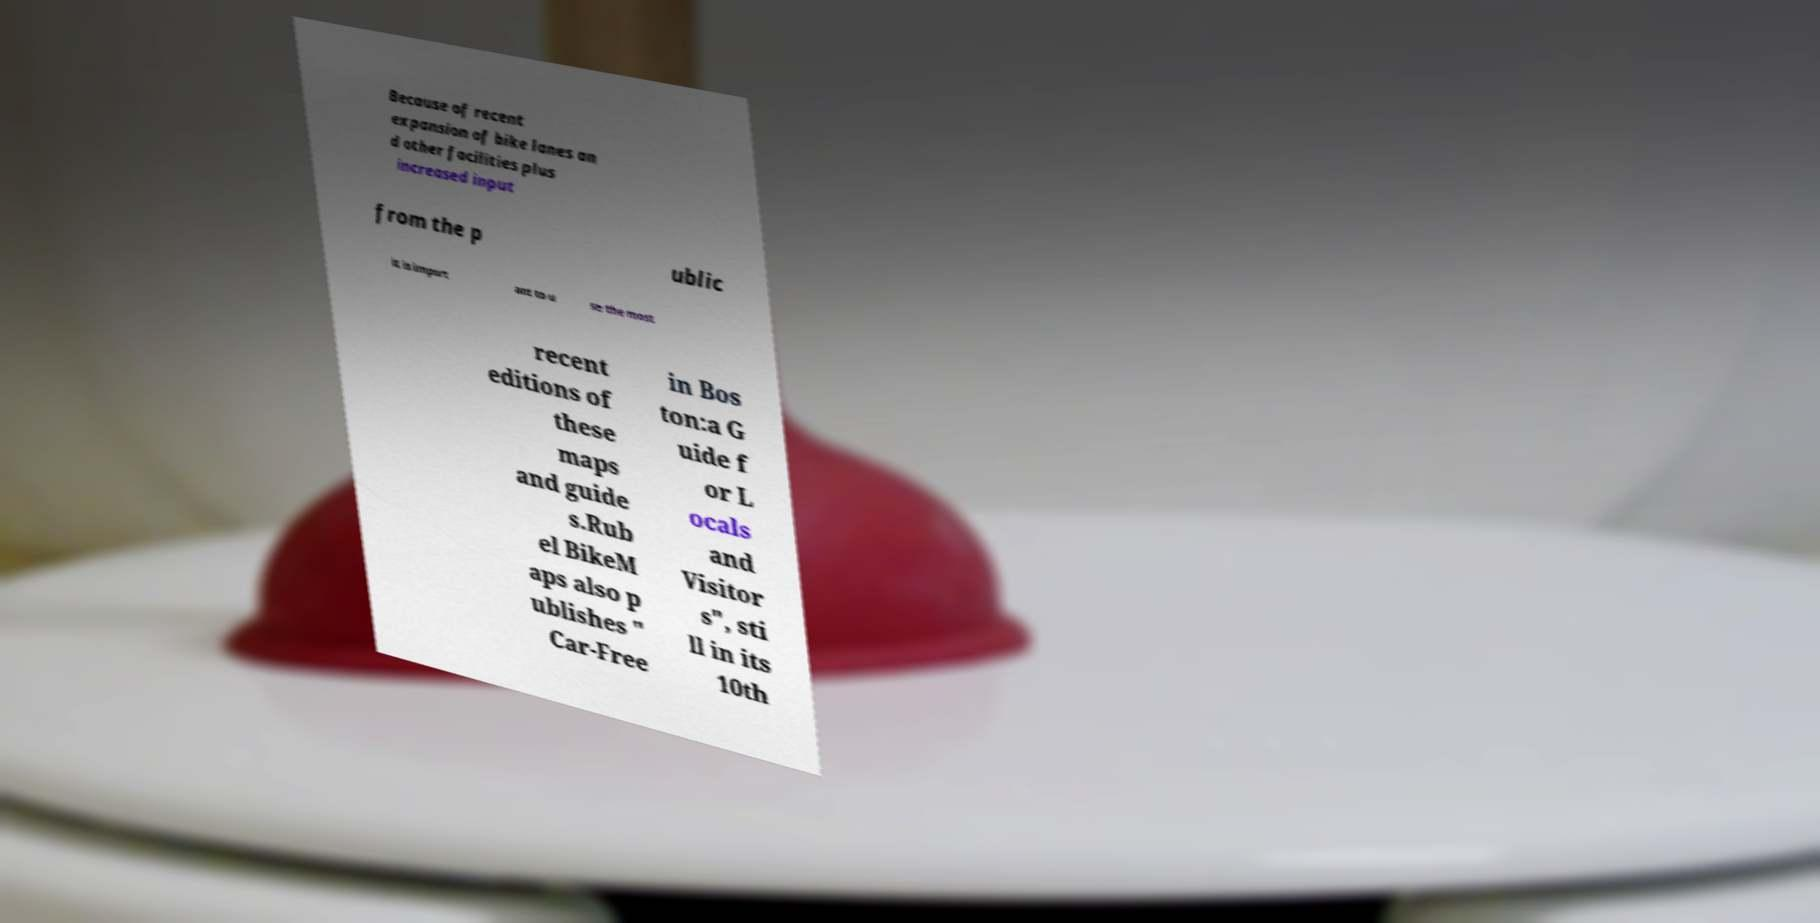There's text embedded in this image that I need extracted. Can you transcribe it verbatim? Because of recent expansion of bike lanes an d other facilities plus increased input from the p ublic it is import ant to u se the most recent editions of these maps and guide s.Rub el BikeM aps also p ublishes " Car-Free in Bos ton:a G uide f or L ocals and Visitor s", sti ll in its 10th 